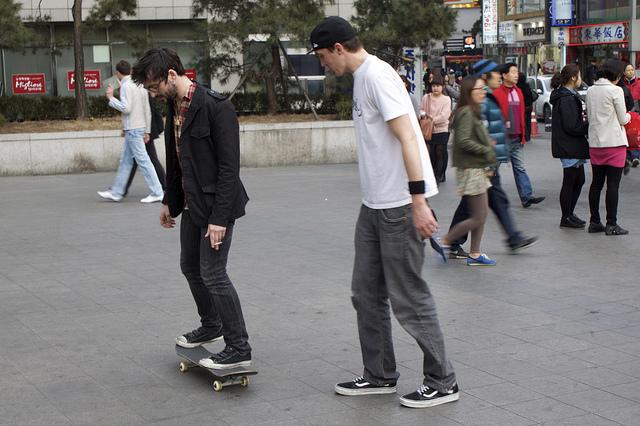What does the man in front have on his left arm?
Short answer required. Wristband. Is it raining?
Keep it brief. No. What is the man holding in the same hand as the envelope?
Concise answer only. Nothing. What color is the man on the right's hat?
Keep it brief. Black. What color are the wheels on the skateboard?
Quick response, please. White. What decade is this photo from?
Write a very short answer. 2000. What color is the shorter man's shirt?
Be succinct. Plaid. What color is the man on the rights pants?
Short answer required. Gray. Are they mother and daughter?
Give a very brief answer. No. What are the people doing?
Answer briefly. Skateboarding. What color is the boy's shirt?
Write a very short answer. White. How many people?
Answer briefly. 11. What is the man on the left standing on?
Write a very short answer. Skateboard. 